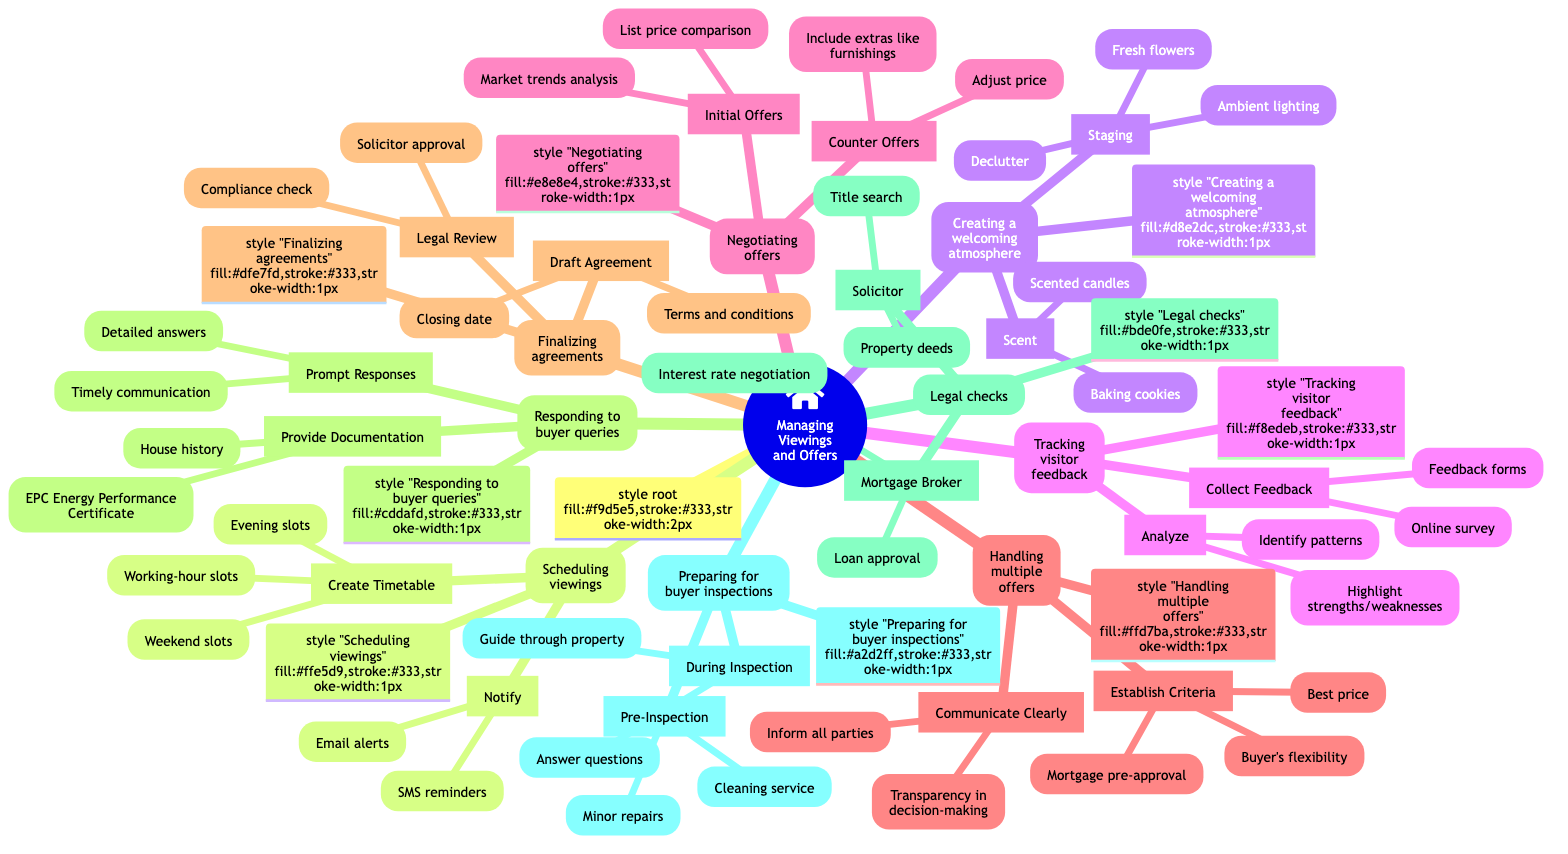What are the two main categories under "Managing Viewings and Offers"? The diagram shows two main categories under "Managing Viewings and Offers": "Scheduling viewings" and "Creating a welcoming atmosphere". The categories can be found directly beneath the root node, emphasizing the organization of tasks related to managing property viewings and offers.
Answer: Scheduling viewings, Creating a welcoming atmosphere How many subcategories does "Creating a welcoming atmosphere" have? In the diagram, "Creating a welcoming atmosphere" has two subcategories: "Staging" and "Scent". This is determined by counting the immediate nodes that fall under this category, which indicates the different aspects of creating an appealing environment for potential buyers.
Answer: 2 What are the two types of responses noted under "Responding to buyer queries"? The two types of responses listed under "Responding to buyer queries" are "Prompt Responses" and "Provide Documentation". These categories identify the approach to addressing buyer inquiries as shown in the specific formatting of the diagram.
Answer: Prompt Responses, Provide Documentation Which aspect is included in "Negotiating offers" that relates to assessing initial offers? The aspect included in "Negotiating offers" that relates to assessing initial offers is "List price comparison". This indicates one of the strategies for evaluating initial offers before deciding on a counteroffer, showing the analytical approach of the process outlined in the diagram.
Answer: List price comparison What criteria are established when handling multiple offers? The criteria established when handling multiple offers include "Best price", "Buyer’s flexibility", and "Mortgage pre-approval". This answer is derived from the information listed under "Handling multiple offers", demonstrating the considerations necessary for evaluating competing offers from potential buyers.
Answer: Best price, Buyer's flexibility, Mortgage pre-approval How many actions are suggested under "Preparing for buyer inspections"? There are two actions suggested under "Preparing for buyer inspections": "Pre-Inspection" and "During Inspection". This is found by identifying the two main points under this category, highlighting the preparatory steps needed for a successful buyer inspection.
Answer: 2 What is required during the "Legal Review" phase when finalizing agreements? During the "Legal Review" phase when finalizing agreements, "Solicitor approval" and "Compliance check" are required. This highlights the necessary steps for ensuring that the agreement meets all legal standards before it can move forward.
Answer: Solicitor approval, Compliance check What should be done first according to "Tracking visitor feedback"? According to "Tracking visitor feedback", the first action should be "Collect Feedback", which involves techniques such as using "Feedback forms" or conducting an "Online survey". This sets the stage for how to gauge visitor interest and impressions of the property after viewings.
Answer: Collect Feedback 